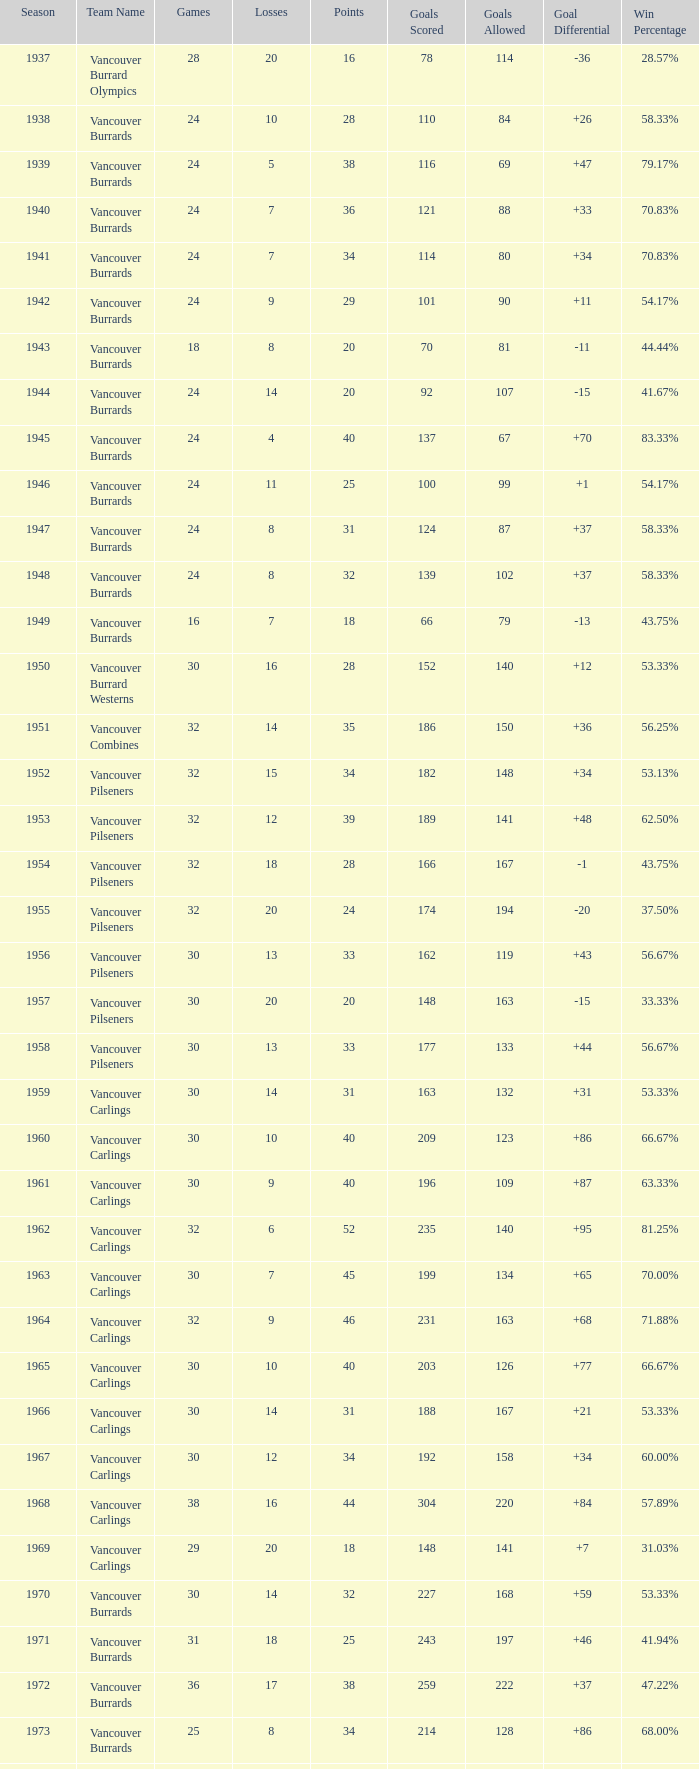What's the lowest number of points with fewer than 8 losses and fewer than 24 games for the vancouver burrards? 18.0. 